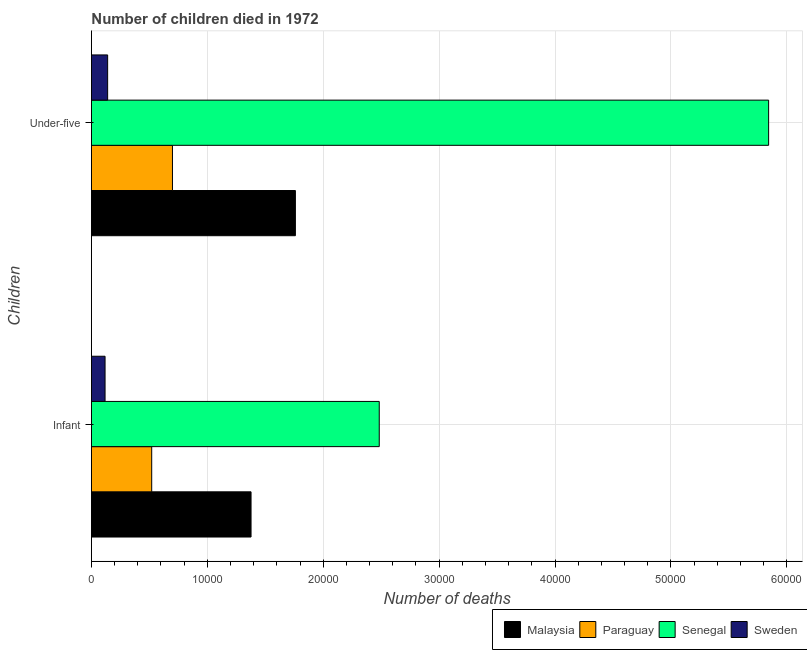Are the number of bars per tick equal to the number of legend labels?
Give a very brief answer. Yes. How many bars are there on the 2nd tick from the bottom?
Your response must be concise. 4. What is the label of the 2nd group of bars from the top?
Offer a terse response. Infant. What is the number of infant deaths in Malaysia?
Offer a terse response. 1.38e+04. Across all countries, what is the maximum number of infant deaths?
Ensure brevity in your answer.  2.48e+04. Across all countries, what is the minimum number of under-five deaths?
Your answer should be compact. 1399. In which country was the number of infant deaths maximum?
Provide a succinct answer. Senegal. What is the total number of under-five deaths in the graph?
Make the answer very short. 8.44e+04. What is the difference between the number of under-five deaths in Senegal and that in Paraguay?
Offer a very short reply. 5.14e+04. What is the difference between the number of infant deaths in Paraguay and the number of under-five deaths in Malaysia?
Your answer should be very brief. -1.24e+04. What is the average number of under-five deaths per country?
Offer a terse response. 2.11e+04. What is the difference between the number of infant deaths and number of under-five deaths in Senegal?
Offer a very short reply. -3.36e+04. What is the ratio of the number of under-five deaths in Paraguay to that in Malaysia?
Your answer should be compact. 0.4. In how many countries, is the number of infant deaths greater than the average number of infant deaths taken over all countries?
Provide a short and direct response. 2. What does the 1st bar from the top in Under-five represents?
Your answer should be very brief. Sweden. What does the 4th bar from the bottom in Infant represents?
Your response must be concise. Sweden. What is the difference between two consecutive major ticks on the X-axis?
Keep it short and to the point. 10000. Are the values on the major ticks of X-axis written in scientific E-notation?
Your answer should be compact. No. What is the title of the graph?
Make the answer very short. Number of children died in 1972. Does "Hungary" appear as one of the legend labels in the graph?
Offer a terse response. No. What is the label or title of the X-axis?
Offer a terse response. Number of deaths. What is the label or title of the Y-axis?
Keep it short and to the point. Children. What is the Number of deaths in Malaysia in Infant?
Ensure brevity in your answer.  1.38e+04. What is the Number of deaths in Paraguay in Infant?
Your answer should be compact. 5201. What is the Number of deaths in Senegal in Infant?
Give a very brief answer. 2.48e+04. What is the Number of deaths of Sweden in Infant?
Offer a very short reply. 1176. What is the Number of deaths in Malaysia in Under-five?
Your response must be concise. 1.76e+04. What is the Number of deaths of Paraguay in Under-five?
Your answer should be very brief. 6992. What is the Number of deaths in Senegal in Under-five?
Your answer should be compact. 5.84e+04. What is the Number of deaths of Sweden in Under-five?
Give a very brief answer. 1399. Across all Children, what is the maximum Number of deaths in Malaysia?
Your answer should be compact. 1.76e+04. Across all Children, what is the maximum Number of deaths in Paraguay?
Keep it short and to the point. 6992. Across all Children, what is the maximum Number of deaths in Senegal?
Your answer should be compact. 5.84e+04. Across all Children, what is the maximum Number of deaths of Sweden?
Provide a short and direct response. 1399. Across all Children, what is the minimum Number of deaths in Malaysia?
Give a very brief answer. 1.38e+04. Across all Children, what is the minimum Number of deaths in Paraguay?
Offer a terse response. 5201. Across all Children, what is the minimum Number of deaths of Senegal?
Your answer should be compact. 2.48e+04. Across all Children, what is the minimum Number of deaths of Sweden?
Offer a terse response. 1176. What is the total Number of deaths of Malaysia in the graph?
Your answer should be very brief. 3.14e+04. What is the total Number of deaths of Paraguay in the graph?
Offer a terse response. 1.22e+04. What is the total Number of deaths of Senegal in the graph?
Give a very brief answer. 8.33e+04. What is the total Number of deaths of Sweden in the graph?
Offer a very short reply. 2575. What is the difference between the Number of deaths of Malaysia in Infant and that in Under-five?
Offer a terse response. -3826. What is the difference between the Number of deaths of Paraguay in Infant and that in Under-five?
Provide a short and direct response. -1791. What is the difference between the Number of deaths of Senegal in Infant and that in Under-five?
Offer a very short reply. -3.36e+04. What is the difference between the Number of deaths in Sweden in Infant and that in Under-five?
Keep it short and to the point. -223. What is the difference between the Number of deaths of Malaysia in Infant and the Number of deaths of Paraguay in Under-five?
Make the answer very short. 6779. What is the difference between the Number of deaths of Malaysia in Infant and the Number of deaths of Senegal in Under-five?
Provide a short and direct response. -4.47e+04. What is the difference between the Number of deaths in Malaysia in Infant and the Number of deaths in Sweden in Under-five?
Give a very brief answer. 1.24e+04. What is the difference between the Number of deaths in Paraguay in Infant and the Number of deaths in Senegal in Under-five?
Ensure brevity in your answer.  -5.32e+04. What is the difference between the Number of deaths in Paraguay in Infant and the Number of deaths in Sweden in Under-five?
Keep it short and to the point. 3802. What is the difference between the Number of deaths of Senegal in Infant and the Number of deaths of Sweden in Under-five?
Your answer should be very brief. 2.34e+04. What is the average Number of deaths of Malaysia per Children?
Keep it short and to the point. 1.57e+04. What is the average Number of deaths in Paraguay per Children?
Ensure brevity in your answer.  6096.5. What is the average Number of deaths of Senegal per Children?
Keep it short and to the point. 4.16e+04. What is the average Number of deaths in Sweden per Children?
Offer a terse response. 1287.5. What is the difference between the Number of deaths in Malaysia and Number of deaths in Paraguay in Infant?
Your answer should be compact. 8570. What is the difference between the Number of deaths in Malaysia and Number of deaths in Senegal in Infant?
Provide a succinct answer. -1.11e+04. What is the difference between the Number of deaths in Malaysia and Number of deaths in Sweden in Infant?
Ensure brevity in your answer.  1.26e+04. What is the difference between the Number of deaths in Paraguay and Number of deaths in Senegal in Infant?
Offer a very short reply. -1.96e+04. What is the difference between the Number of deaths in Paraguay and Number of deaths in Sweden in Infant?
Your answer should be compact. 4025. What is the difference between the Number of deaths of Senegal and Number of deaths of Sweden in Infant?
Provide a succinct answer. 2.37e+04. What is the difference between the Number of deaths in Malaysia and Number of deaths in Paraguay in Under-five?
Give a very brief answer. 1.06e+04. What is the difference between the Number of deaths of Malaysia and Number of deaths of Senegal in Under-five?
Provide a succinct answer. -4.08e+04. What is the difference between the Number of deaths in Malaysia and Number of deaths in Sweden in Under-five?
Make the answer very short. 1.62e+04. What is the difference between the Number of deaths in Paraguay and Number of deaths in Senegal in Under-five?
Ensure brevity in your answer.  -5.14e+04. What is the difference between the Number of deaths in Paraguay and Number of deaths in Sweden in Under-five?
Ensure brevity in your answer.  5593. What is the difference between the Number of deaths in Senegal and Number of deaths in Sweden in Under-five?
Your answer should be very brief. 5.70e+04. What is the ratio of the Number of deaths of Malaysia in Infant to that in Under-five?
Keep it short and to the point. 0.78. What is the ratio of the Number of deaths in Paraguay in Infant to that in Under-five?
Provide a short and direct response. 0.74. What is the ratio of the Number of deaths in Senegal in Infant to that in Under-five?
Offer a terse response. 0.42. What is the ratio of the Number of deaths in Sweden in Infant to that in Under-five?
Offer a very short reply. 0.84. What is the difference between the highest and the second highest Number of deaths of Malaysia?
Your answer should be very brief. 3826. What is the difference between the highest and the second highest Number of deaths of Paraguay?
Provide a short and direct response. 1791. What is the difference between the highest and the second highest Number of deaths of Senegal?
Offer a very short reply. 3.36e+04. What is the difference between the highest and the second highest Number of deaths of Sweden?
Offer a terse response. 223. What is the difference between the highest and the lowest Number of deaths in Malaysia?
Offer a terse response. 3826. What is the difference between the highest and the lowest Number of deaths of Paraguay?
Offer a very short reply. 1791. What is the difference between the highest and the lowest Number of deaths of Senegal?
Provide a short and direct response. 3.36e+04. What is the difference between the highest and the lowest Number of deaths in Sweden?
Keep it short and to the point. 223. 